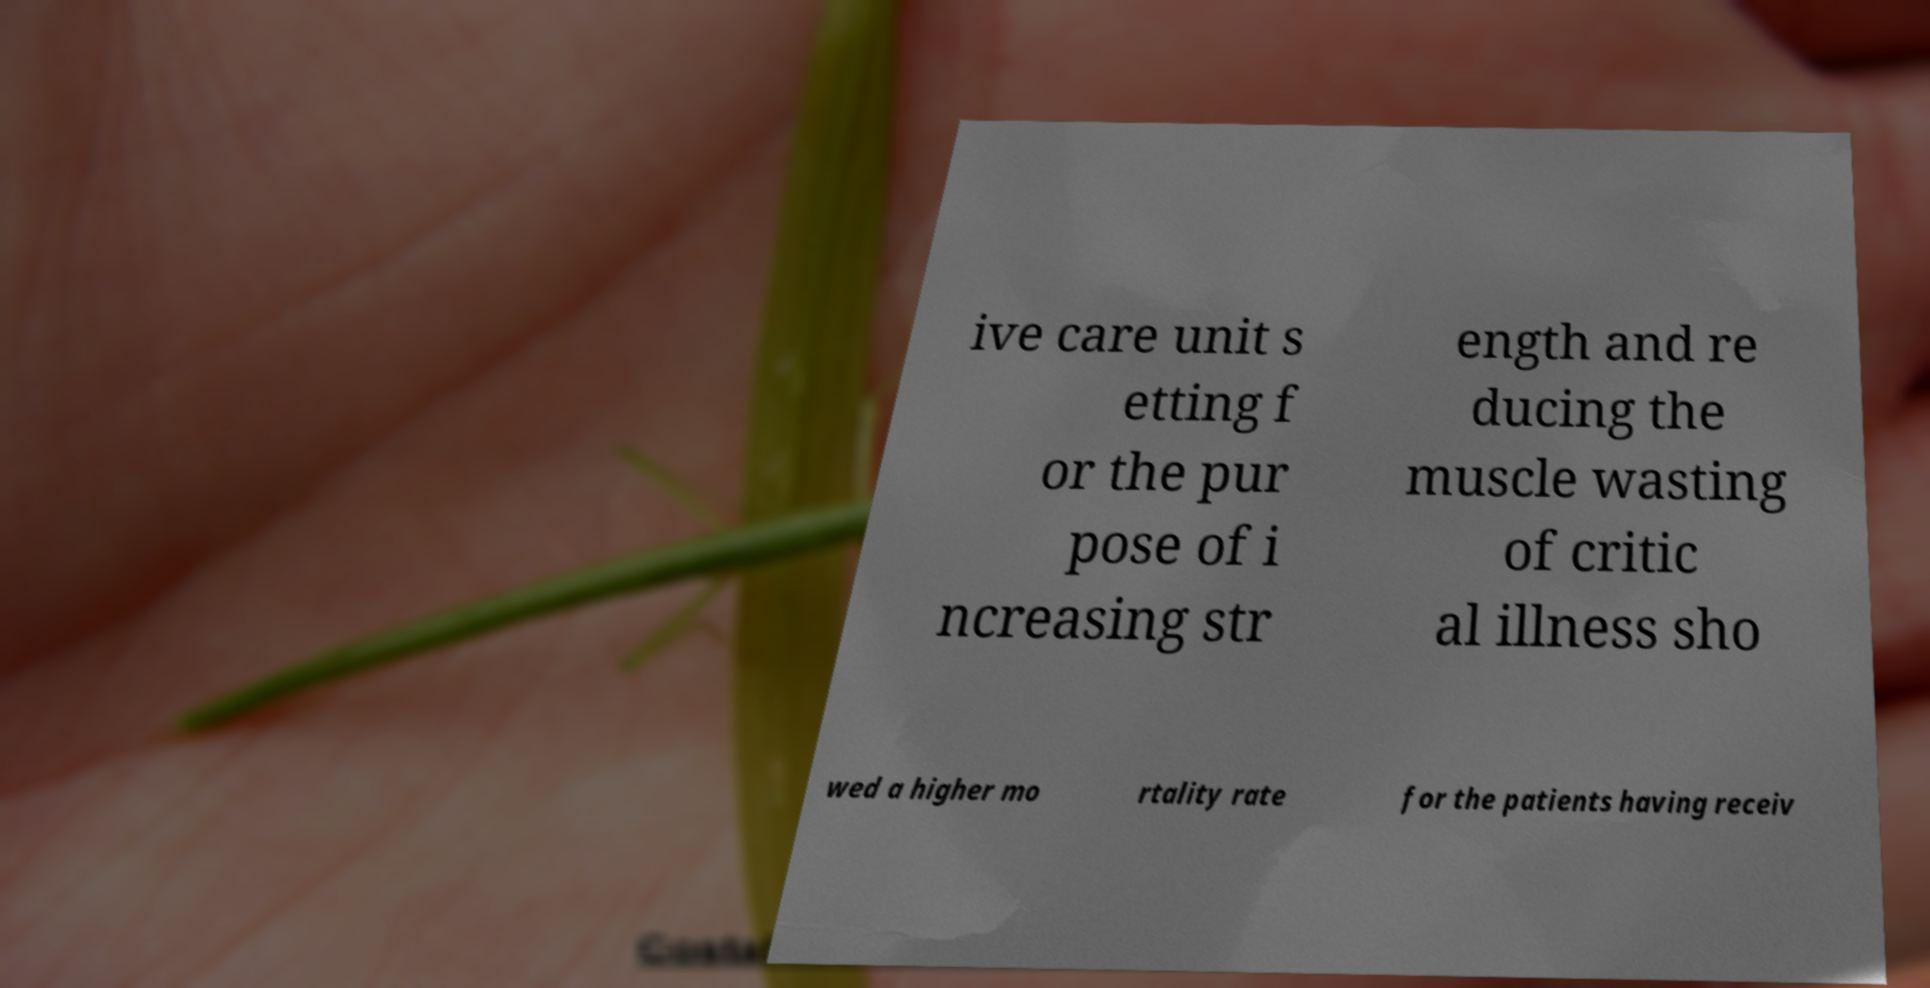Can you accurately transcribe the text from the provided image for me? ive care unit s etting f or the pur pose of i ncreasing str ength and re ducing the muscle wasting of critic al illness sho wed a higher mo rtality rate for the patients having receiv 